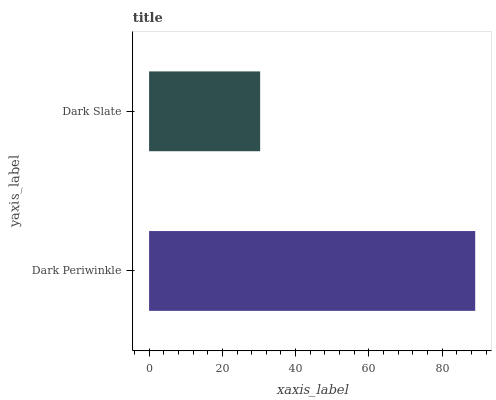Is Dark Slate the minimum?
Answer yes or no. Yes. Is Dark Periwinkle the maximum?
Answer yes or no. Yes. Is Dark Slate the maximum?
Answer yes or no. No. Is Dark Periwinkle greater than Dark Slate?
Answer yes or no. Yes. Is Dark Slate less than Dark Periwinkle?
Answer yes or no. Yes. Is Dark Slate greater than Dark Periwinkle?
Answer yes or no. No. Is Dark Periwinkle less than Dark Slate?
Answer yes or no. No. Is Dark Periwinkle the high median?
Answer yes or no. Yes. Is Dark Slate the low median?
Answer yes or no. Yes. Is Dark Slate the high median?
Answer yes or no. No. Is Dark Periwinkle the low median?
Answer yes or no. No. 